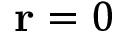Convert formula to latex. <formula><loc_0><loc_0><loc_500><loc_500>r = 0</formula> 